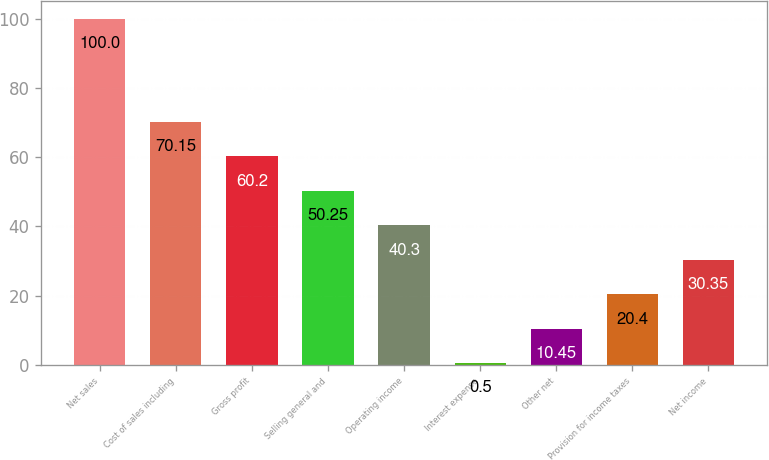Convert chart. <chart><loc_0><loc_0><loc_500><loc_500><bar_chart><fcel>Net sales<fcel>Cost of sales including<fcel>Gross profit<fcel>Selling general and<fcel>Operating income<fcel>Interest expense<fcel>Other net<fcel>Provision for income taxes<fcel>Net income<nl><fcel>100<fcel>70.15<fcel>60.2<fcel>50.25<fcel>40.3<fcel>0.5<fcel>10.45<fcel>20.4<fcel>30.35<nl></chart> 